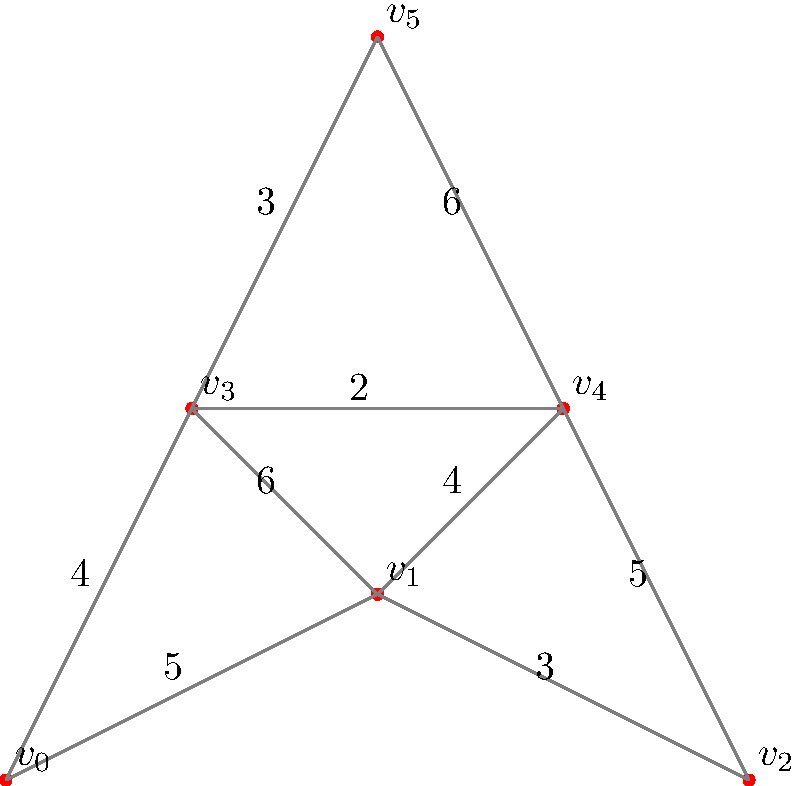As a sustainable rubber tree plantation owner, you want to determine the most efficient harvesting route through your plantation. The plantation layout is represented by the graph above, where vertices represent collection points and edge weights represent distances between points in kilometers. Using Kruskal's algorithm, find the minimum spanning tree and calculate the total distance of the optimal harvesting route. To find the minimum spanning tree using Kruskal's algorithm and calculate the total distance, we'll follow these steps:

1. Sort all edges in ascending order of weight:
   (3,4): 2
   (3,5): 3
   (1,2): 3
   (0,3): 4
   (1,4): 4
   (0,1): 5
   (2,4): 5
   (1,3): 6
   (4,5): 6

2. Start with an empty set of edges and add edges that don't create cycles:
   - Add (3,4): 2
   - Add (3,5): 3
   - Add (1,2): 3
   - Add (0,3): 4
   - Add (1,4): 4

3. The minimum spanning tree is complete with 5 edges (for 6 vertices).

4. Calculate the total distance by summing the weights of the selected edges:
   Total distance = 2 + 3 + 3 + 4 + 4 = 16 km

Therefore, the minimum spanning tree consists of the edges (3,4), (3,5), (1,2), (0,3), and (1,4), with a total distance of 16 km.
Answer: 16 km 